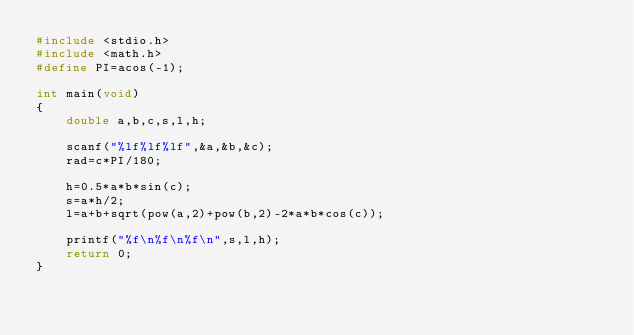<code> <loc_0><loc_0><loc_500><loc_500><_C_>#include <stdio.h>
#include <math.h>
#define PI=acos(-1);

int main(void)
{
    double a,b,c,s,l,h;
    
    scanf("%lf%lf%lf",&a,&b,&c);
    rad=c*PI/180;
    
    h=0.5*a*b*sin(c);
    s=a*h/2;
    l=a+b+sqrt(pow(a,2)+pow(b,2)-2*a*b*cos(c));
    
    printf("%f\n%f\n%f\n",s,l,h);
    return 0;
}
</code> 